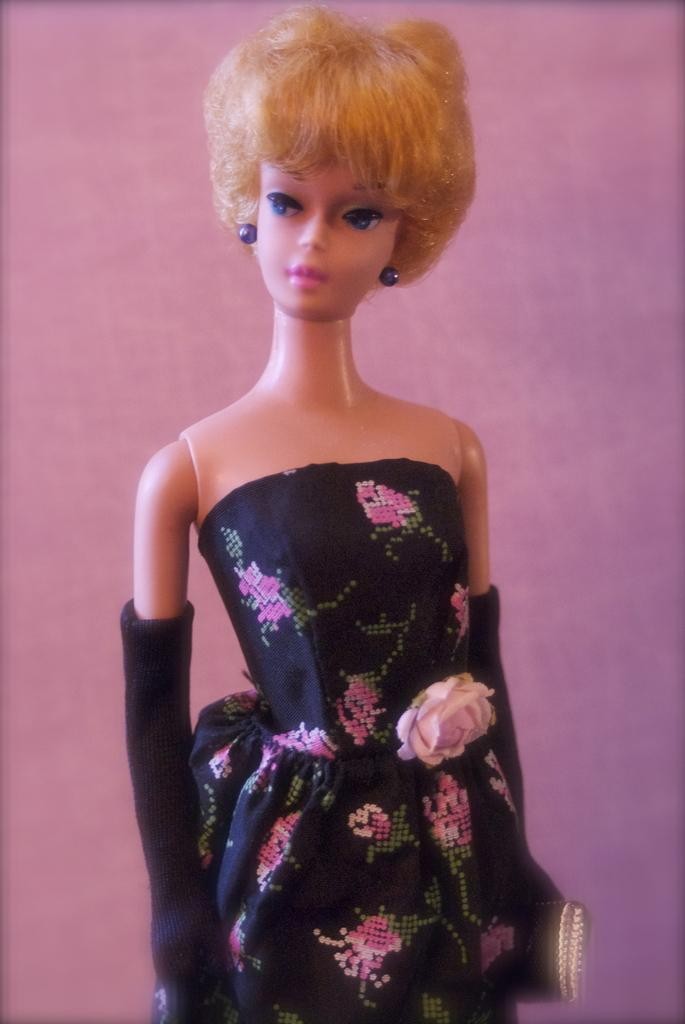What is the main subject of the image? There is a doll in the image. What else can be seen in the image besides the doll? There is a cloth in the image. What color is the background of the image? The background of the image is pink. What type of tongue can be seen in the image? There is no tongue present in the image. Is there a fireman in the image? No, there is no fireman in the image. 